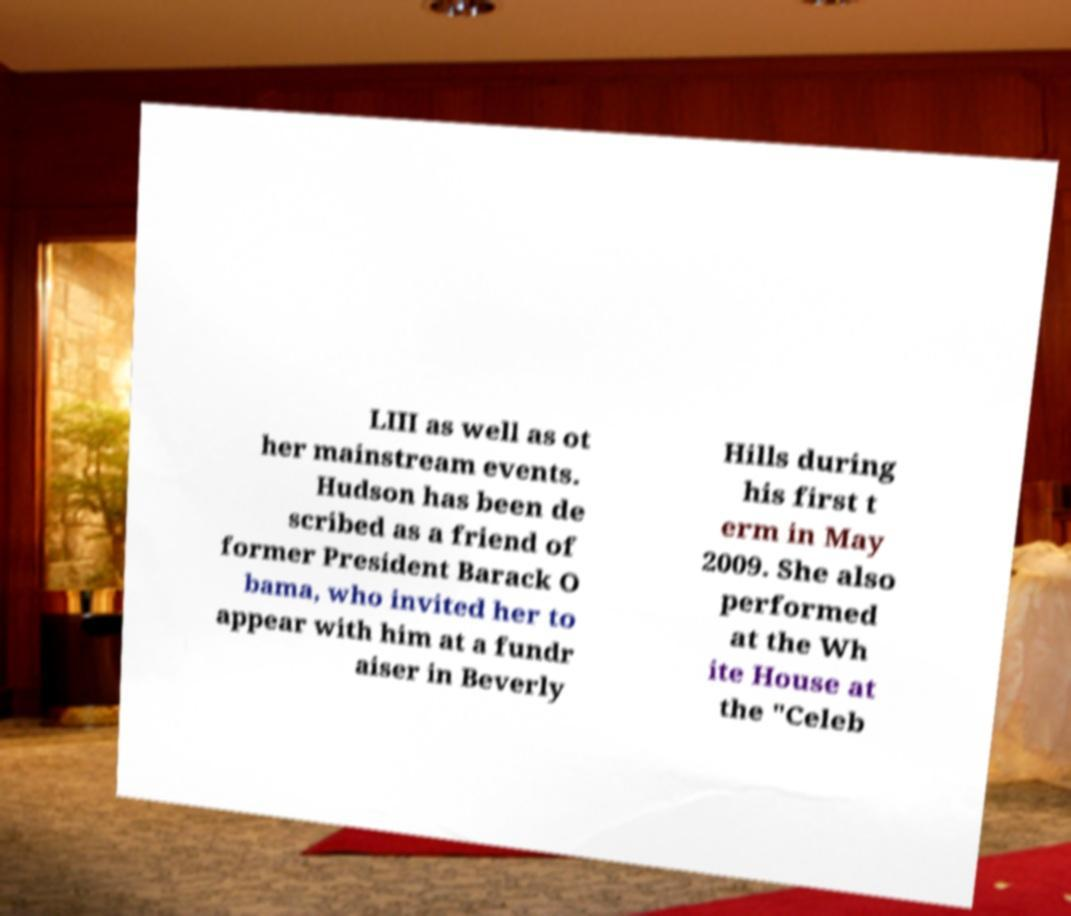What messages or text are displayed in this image? I need them in a readable, typed format. LIII as well as ot her mainstream events. Hudson has been de scribed as a friend of former President Barack O bama, who invited her to appear with him at a fundr aiser in Beverly Hills during his first t erm in May 2009. She also performed at the Wh ite House at the "Celeb 